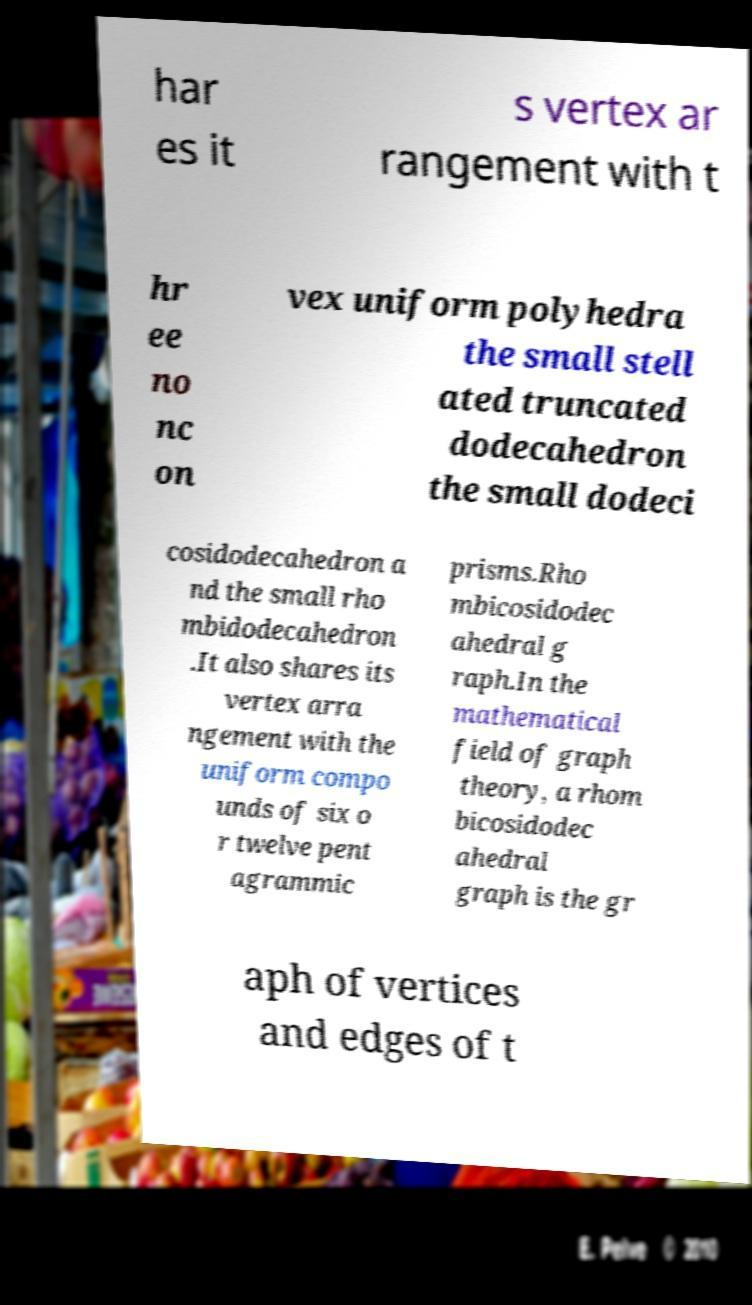Please read and relay the text visible in this image. What does it say? har es it s vertex ar rangement with t hr ee no nc on vex uniform polyhedra the small stell ated truncated dodecahedron the small dodeci cosidodecahedron a nd the small rho mbidodecahedron .It also shares its vertex arra ngement with the uniform compo unds of six o r twelve pent agrammic prisms.Rho mbicosidodec ahedral g raph.In the mathematical field of graph theory, a rhom bicosidodec ahedral graph is the gr aph of vertices and edges of t 